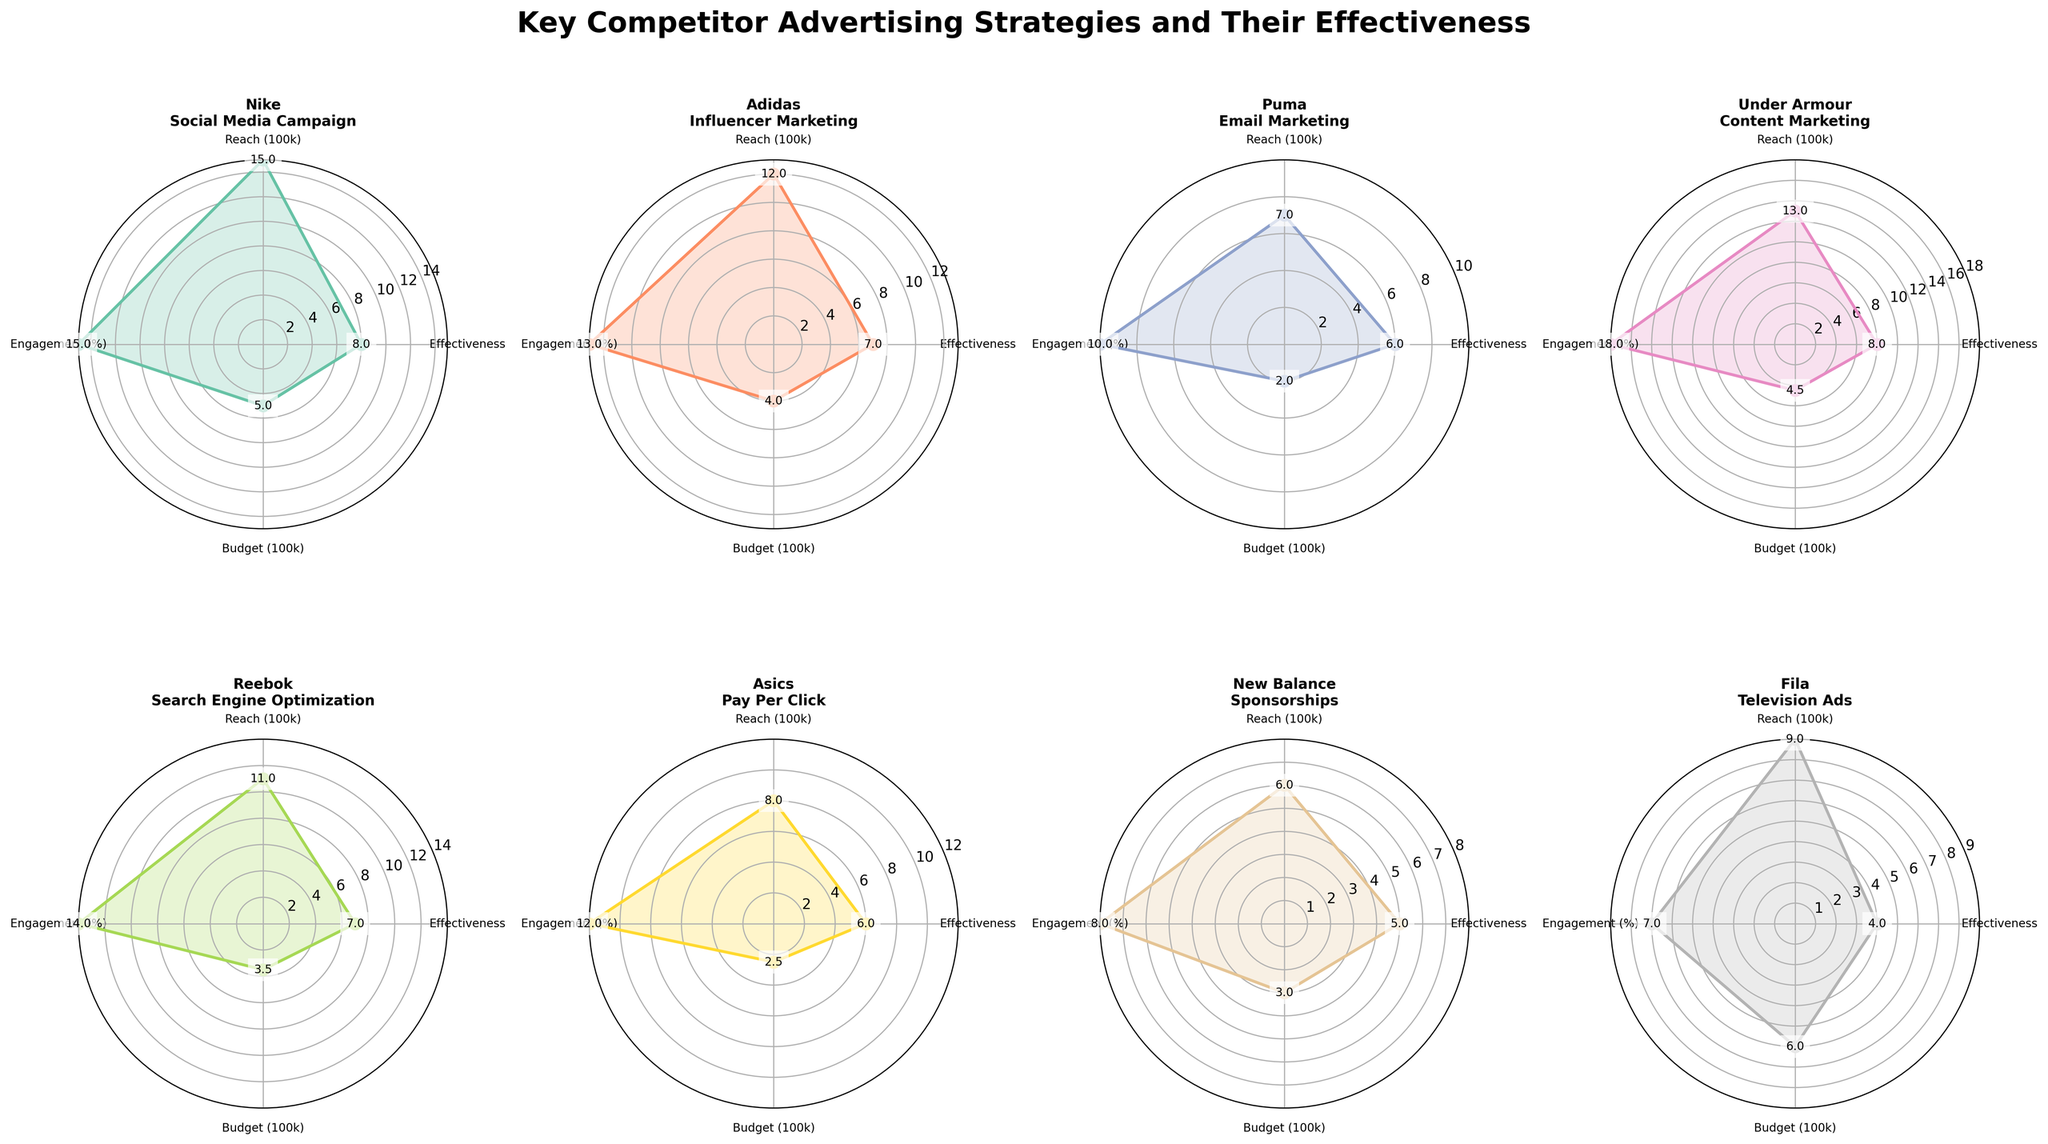What's the title of the figure? The title of the figure is displayed prominently at the top of the plots. It summarizes the main topic of the visual representation.
Answer: Key Competitor Advertising Strategies and Their Effectiveness How many companies are displayed in the subplots? By looking at the individual titles within each subplot, we can count the companies represented.
Answer: 8 Which company has the highest effectiveness rating? By comparing the "Effectiveness" values represented at the respective angles in each subplot, identify the highest value. Nike and Under Armour both have an effectiveness rating of 8, but we'll confirm by reading the titles as well.
Answer: Nike and Under Armour What is the budget for Reebok's strategy? Locate the subplot for Reebok and check the "Budget" value at the respective angle.
Answer: 350,000 Which company has the lowest engagement rate and what is it? Compare the "Engagement" values within each subplot. Locate the smallest value and identify the corresponding company. Fila has the lowest engagement rate.
Answer: Fila, 0.07 Which company achieved the highest audience reach, and what was the value? Compare the "Reach" values within each subplot. Nike has the highest reach value.
Answer: Nike, 1,500,000 What is the average effectiveness rating across all companies? Sum the effectiveness ratings of all companies and divide by the number of companies. (8 + 7 + 6 + 8 + 7 + 6 + 5 + 4) / 8 = 6.375
Answer: 6.375 Who invested the most in their advertising strategy, and what was the budget? Locate the subplot that shows the highest "Budget" value and identify the respective company. Fila has the highest budget.
Answer: Fila, 600,000 Which two companies have the same effectiveness rating and what is the value? Identify the effectiveness values in each subplot. Nike and Under Armour have the same effectiveness rating.
Answer: Nike and Under Armour, 8 Between Adidas and Puma, which company had a better reach and by how much? Compare the reach values for Adidas and Puma. Adidas (1,200,000) - Puma (700,000) = 500,000
Answer: Adidas by 500,000 